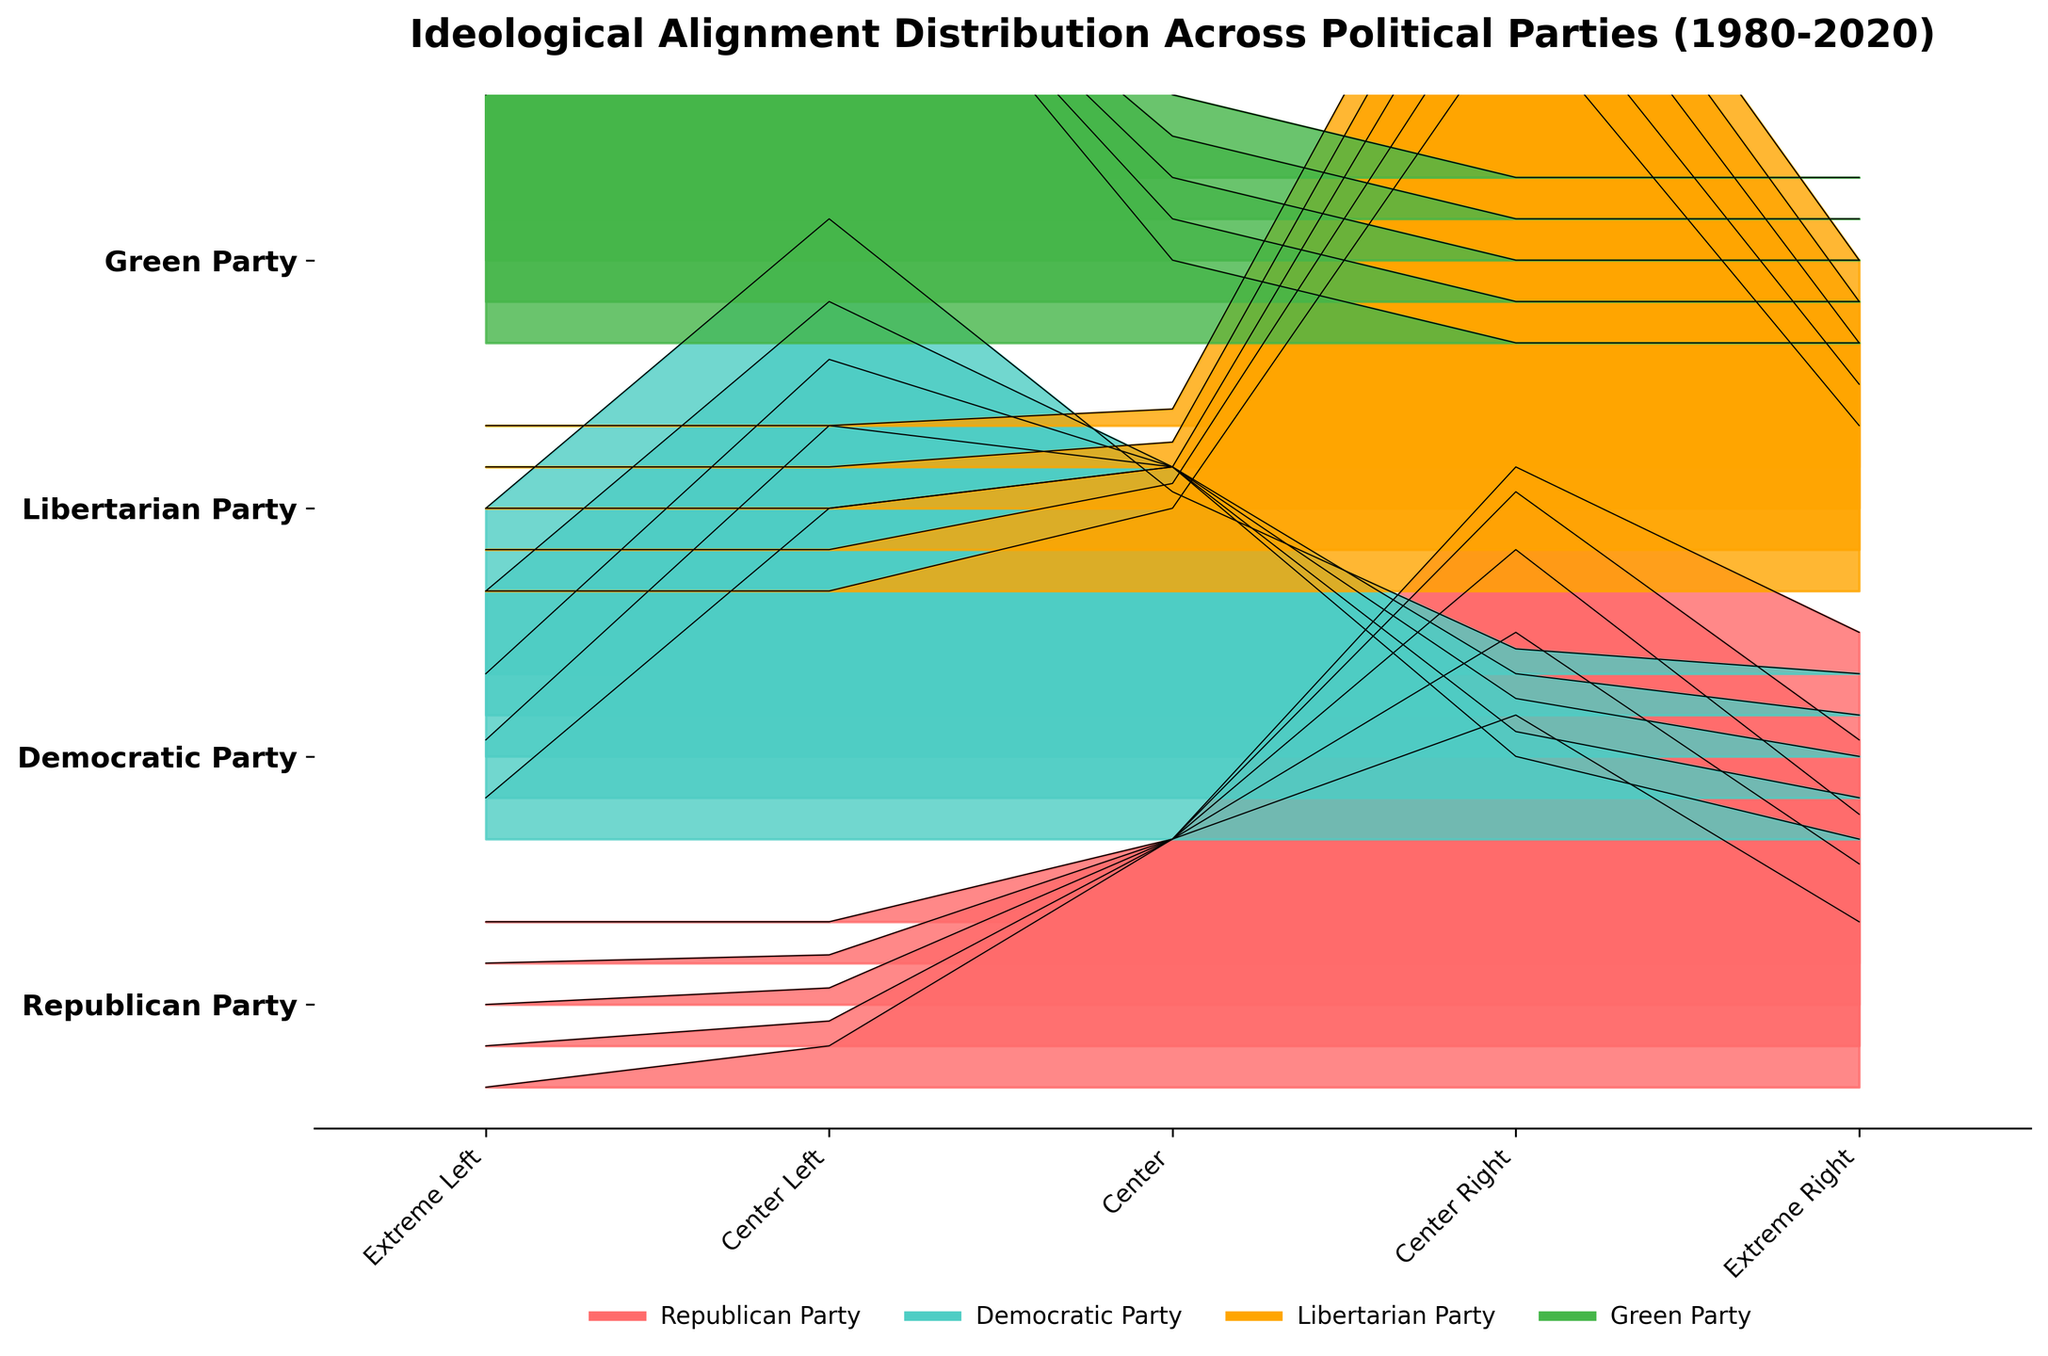What is the color used to represent the Democratic Party? The Democratic Party is represented using turquoise blue, as indicated by the color legend at the bottom of the figure.
Answer: Turquoise blue What is the main title of the figure? The title is located at the top of the figure and describes the main content or topic being visualized, which is the ideological alignment distribution across political parties from 1980-2020.
Answer: Ideological Alignment Distribution Across Political Parties (1980-2020) Which party shows an increasing trend towards the extreme left from 1980 to 2020? By examining the trends in the ridgeline plots, the Green Party shows an increase in the proportion of members in the extreme left category, growing from 30% in 1980 to 50% in 2020.
Answer: Green Party What is the ideological alignment with the highest percentage for the Libertarian Party in 2020? The tallest segment in the Libertarian Party’s ridgeline for 2020 shows ideological alignment. The tallest segment corresponds to the 'center right' with around 78%.
Answer: Center Right Which party has the least percentage of members in the extreme left category in 2020 and what is that percentage? By comparing the section heights for all parties for the extreme left category in 2020, the Republican and Libertarian parties both have 0% in the extreme left category.
Answer: Republican Party and Libertarian Party, 0% In what year did the Republican Party have the highest percentage of members aligned with center-right ideology? Looking at the height of the center-right segment for the Republican Party across the years, it’s highest in 2020 with 55%.
Answer: 2020 How did the percentage of Republican Party members in the center ideology change from 1980 to 2020? By examining the proportions for the Republican Party's center category, it decreases from 30% in 1980 to 10% in 2020. This is found by checking the height of the 'center' segment in the ridgeline plot for those years.
Answer: Decreased from 30% to 10% Compare the trend in the center-left ideology for the Democratic Party from 1980 to 2020. Analyze the changes in the heights of the center-left section for the Democratic Party at different times. The percentage increases from 40% in 1980 to 55% in 2020.
Answer: Increased from 40% to 55% Between the Republican Party and the Democratic Party, which one shows a greater ideological shift towards the extreme ends (extreme left or extreme right) from 1980 to 2020? Examine the changes in proportions for the extreme left and extreme right categories for both parties across the years 1980 to 2020. The Republican Party has shifted more towards the extreme right (from 20% to 35%), while the Democratic Party has moved more towards the extreme left (from 5% to 20%). Hence, the Republican shift is greater.
Answer: Republican Party, towards extreme right How does the distribution of ideological alignment in the Green Party compare to other parties in terms of variability over the years? Look at the shape and variability in section heights for the Green Party compared to others over the years. The Green Party shows more stability across the extreme left and center-left categories, whereas other parties have more variation across the ideological spectrum.
Answer: Green Party is more stable בעל (consistent) 